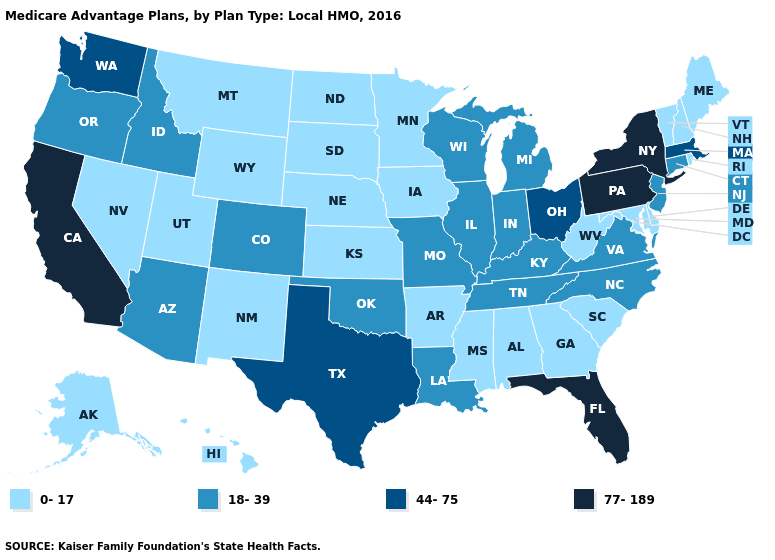Which states have the highest value in the USA?
Be succinct. California, Florida, New York, Pennsylvania. What is the value of New Mexico?
Quick response, please. 0-17. Among the states that border Arkansas , which have the lowest value?
Answer briefly. Mississippi. What is the highest value in the USA?
Be succinct. 77-189. Name the states that have a value in the range 0-17?
Be succinct. Alaska, Alabama, Arkansas, Delaware, Georgia, Hawaii, Iowa, Kansas, Maryland, Maine, Minnesota, Mississippi, Montana, North Dakota, Nebraska, New Hampshire, New Mexico, Nevada, Rhode Island, South Carolina, South Dakota, Utah, Vermont, West Virginia, Wyoming. Which states have the lowest value in the MidWest?
Short answer required. Iowa, Kansas, Minnesota, North Dakota, Nebraska, South Dakota. Does Delaware have the highest value in the USA?
Keep it brief. No. Which states hav the highest value in the MidWest?
Short answer required. Ohio. Does North Carolina have the highest value in the South?
Answer briefly. No. Name the states that have a value in the range 77-189?
Short answer required. California, Florida, New York, Pennsylvania. Which states hav the highest value in the Northeast?
Answer briefly. New York, Pennsylvania. What is the value of Alaska?
Concise answer only. 0-17. Which states have the lowest value in the West?
Be succinct. Alaska, Hawaii, Montana, New Mexico, Nevada, Utah, Wyoming. Does Pennsylvania have the same value as New York?
Concise answer only. Yes. Name the states that have a value in the range 77-189?
Keep it brief. California, Florida, New York, Pennsylvania. 